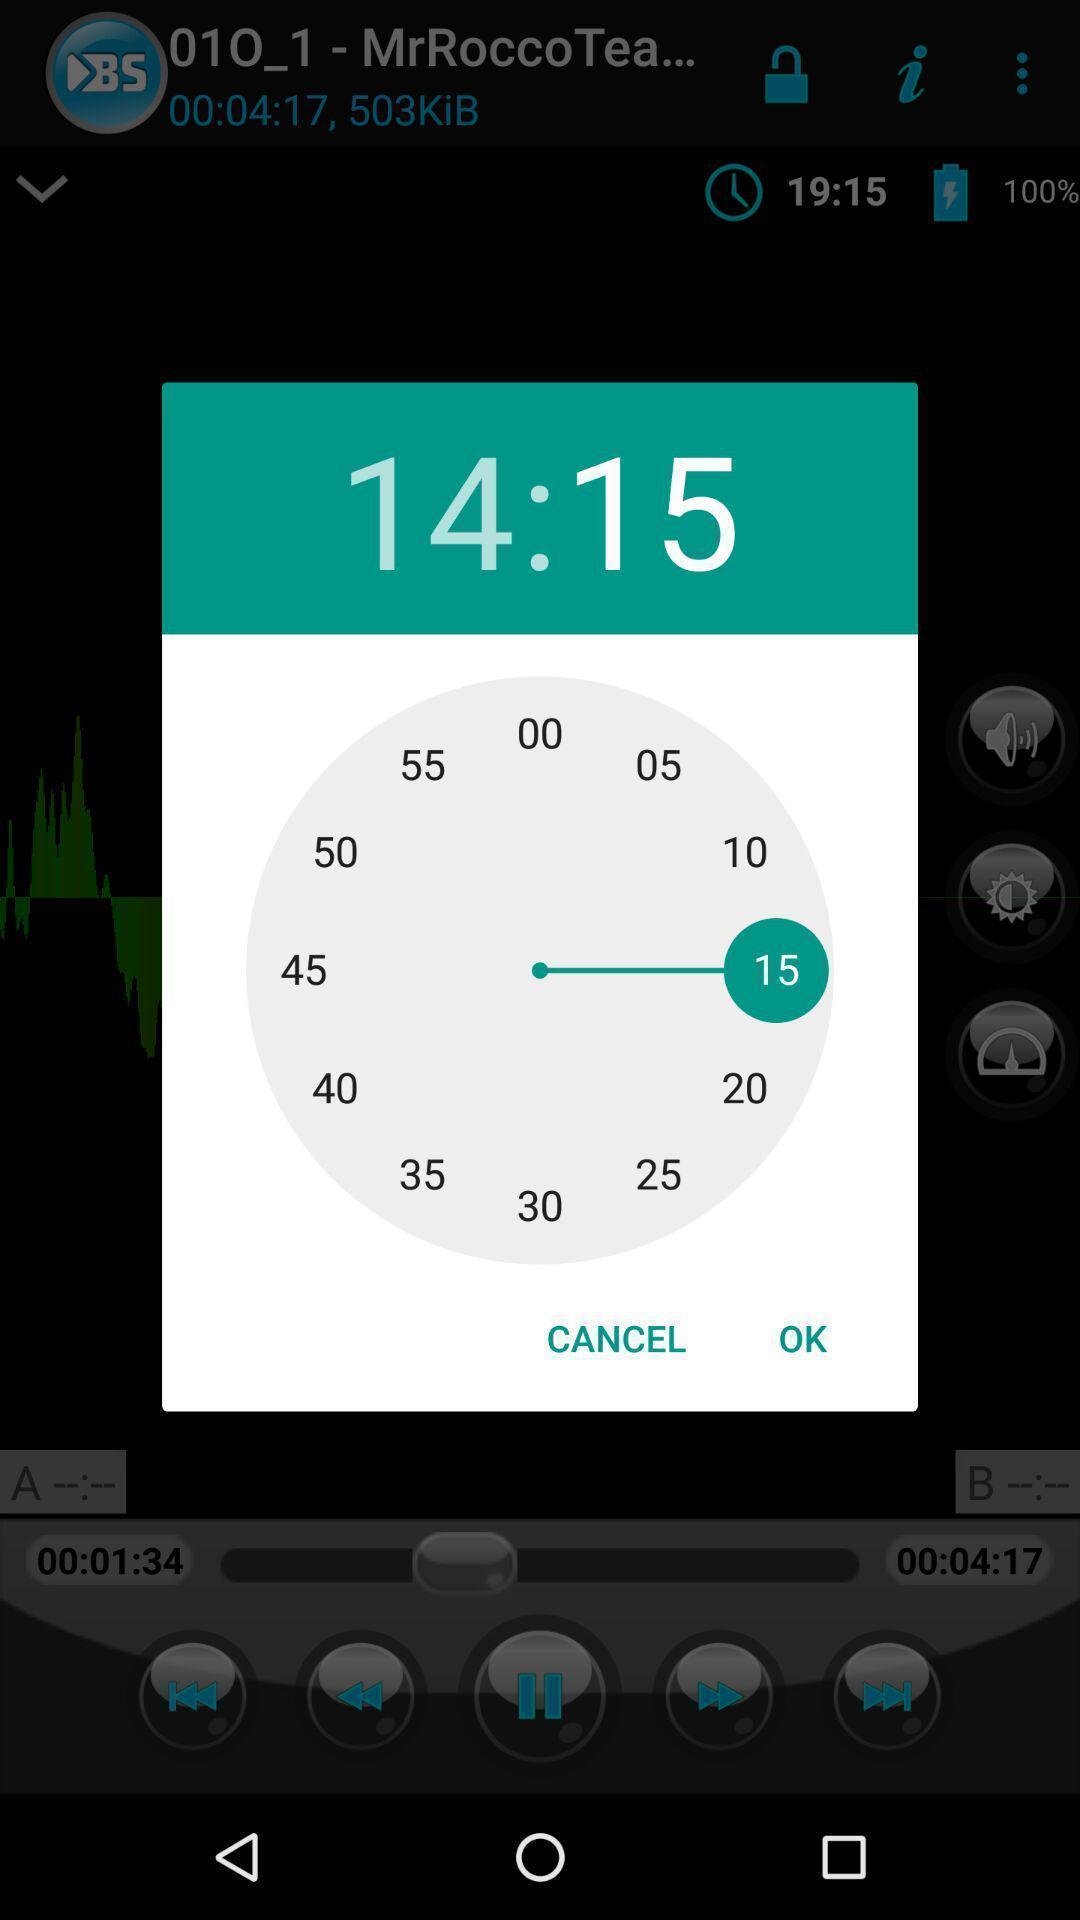Describe the content in this image. Screen displaying the pop-up of a clock. 